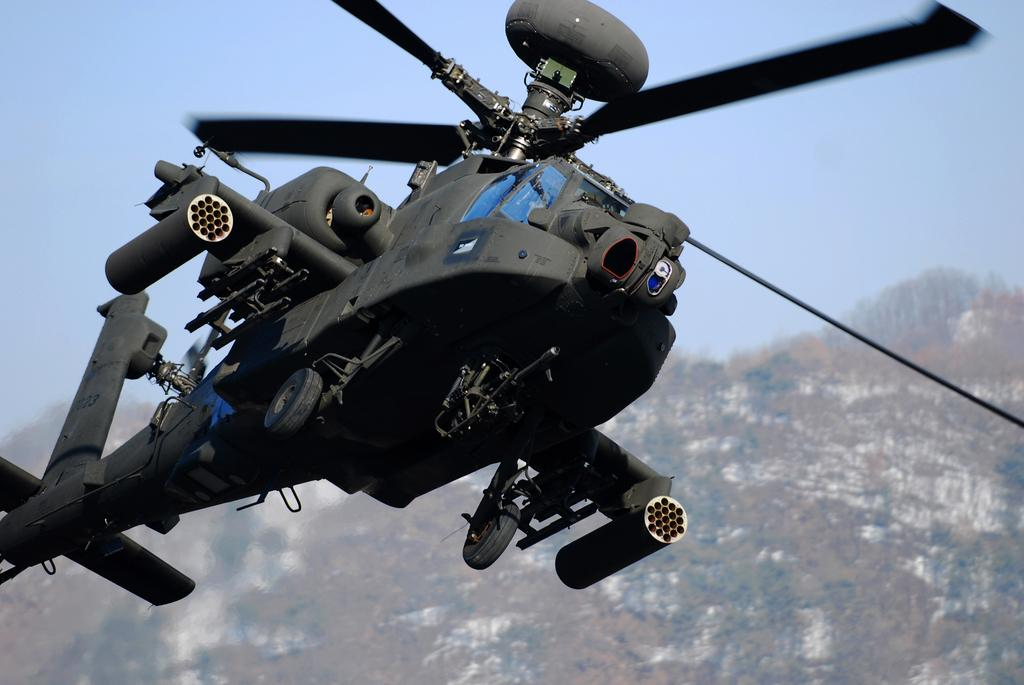What is the main subject of the image? The main subject of the image is a helicopter. Where is the helicopter located in the image? The helicopter is in the air. What can be seen in the background of the image? There are trees, mountains, and the sky visible in the background of the image. Can you see any veins in the image? There are no veins present in the image; it features a helicopter in the air with a background of trees, mountains, and the sky. 